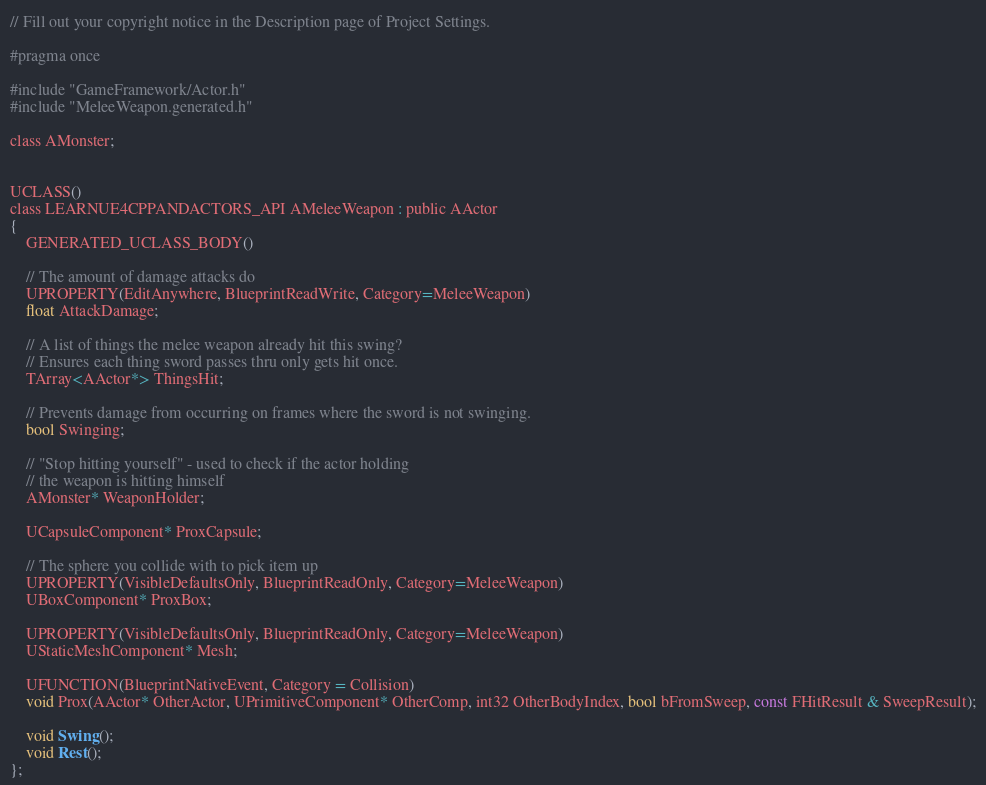<code> <loc_0><loc_0><loc_500><loc_500><_C_>// Fill out your copyright notice in the Description page of Project Settings.

#pragma once

#include "GameFramework/Actor.h"
#include "MeleeWeapon.generated.h"

class AMonster;


UCLASS()
class LEARNUE4CPPANDACTORS_API AMeleeWeapon : public AActor
{
    GENERATED_UCLASS_BODY()

    // The amount of damage attacks do
    UPROPERTY(EditAnywhere, BlueprintReadWrite, Category=MeleeWeapon)
    float AttackDamage;
    
    // A list of things the melee weapon already hit this swing?
    // Ensures each thing sword passes thru only gets hit once.
    TArray<AActor*> ThingsHit;
    
    // Prevents damage from occurring on frames where the sword is not swinging.
    bool Swinging;
    
    // "Stop hitting yourself" - used to check if the actor holding
    // the weapon is hitting himself
    AMonster* WeaponHolder;
    
    UCapsuleComponent* ProxCapsule;
    
    // The sphere you collide with to pick item up
    UPROPERTY(VisibleDefaultsOnly, BlueprintReadOnly, Category=MeleeWeapon)
    UBoxComponent* ProxBox;
    
    UPROPERTY(VisibleDefaultsOnly, BlueprintReadOnly, Category=MeleeWeapon)
    UStaticMeshComponent* Mesh;
    
    UFUNCTION(BlueprintNativeEvent, Category = Collision)
    void Prox(AActor* OtherActor, UPrimitiveComponent* OtherComp, int32 OtherBodyIndex, bool bFromSweep, const FHitResult & SweepResult);
    
    void Swing();
    void Rest();
};
</code> 